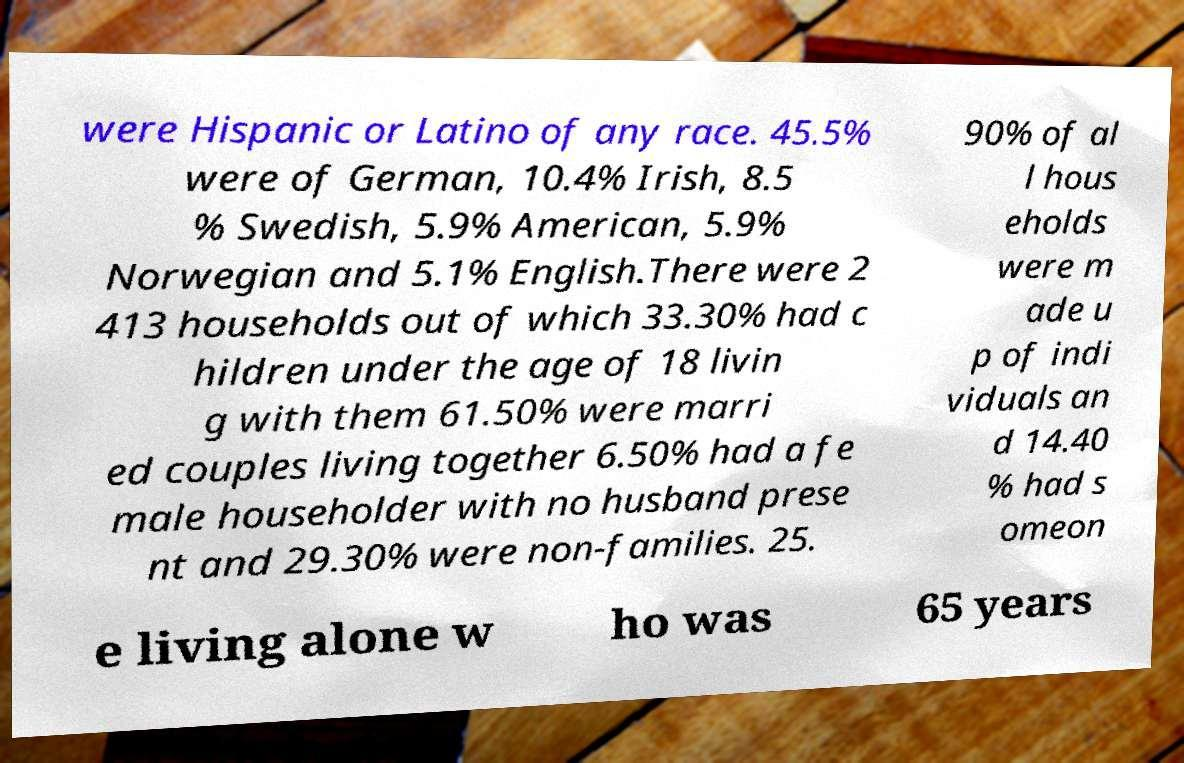What messages or text are displayed in this image? I need them in a readable, typed format. were Hispanic or Latino of any race. 45.5% were of German, 10.4% Irish, 8.5 % Swedish, 5.9% American, 5.9% Norwegian and 5.1% English.There were 2 413 households out of which 33.30% had c hildren under the age of 18 livin g with them 61.50% were marri ed couples living together 6.50% had a fe male householder with no husband prese nt and 29.30% were non-families. 25. 90% of al l hous eholds were m ade u p of indi viduals an d 14.40 % had s omeon e living alone w ho was 65 years 